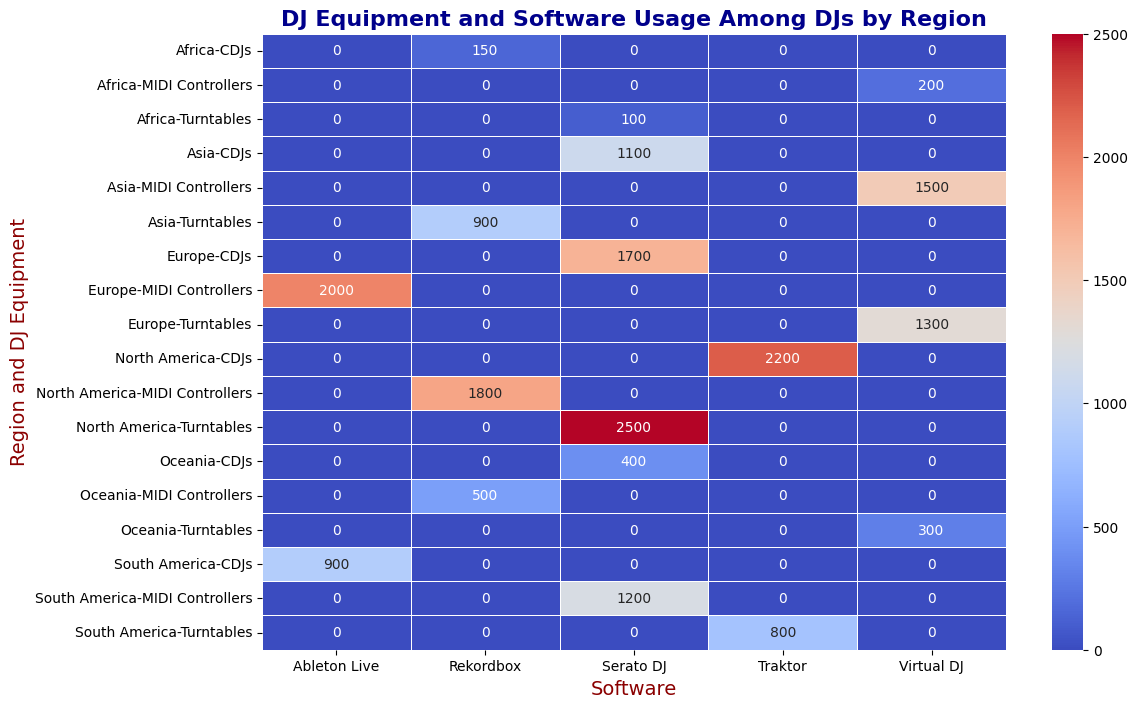Which region has the highest number of users for Serato DJ? To find this, locate the cells in the heatmap where the Software is "Serato DJ". North America, Europe, Asia, South America, and Oceania all have numbers in the "Serato DJ" column. Comparing these values shows that North America has the highest number of users with 2500 for Serato DJ.
Answer: North America What is the sum of users of Rekordbox in all regions? Add up the users from the cells in the "Rekordbox" column. According to the data: North America (1800), Asia (900), Oceania (500), and Africa (150). The total is 1800 + 900 + 500 + 150 = 3350.
Answer: 3350 Which piece of equipment is most widely used in Europe? To determine this, sum the user numbers for each piece of equipment under Europe. For Turntables, users are 1300; MIDI Controllers have 2000 users; CDJs have 1700 users. The highest number is 2000 for MIDI Controllers.
Answer: MIDI Controllers Compare the usage of Traktor software between North America and South America. Locate the cells where the Software is "Traktor" for North and South America. North America has 2200 users, while South America has 800 users. North America's usage is higher (2200 vs. 800).
Answer: North America Which software is the least used among DJs in Asia? Compare the user numbers for Asia across all software columns. The software numbers for Asia are: Rekordbox (900), Virtual DJ (1500), and Serato DJ (1100). Rekordbox has the smallest number of users.
Answer: Rekordbox What is the average number of users for Virtual DJ across all regions? Sum the users for Virtual DJ across all regions and divide by the number of regions using this software. The users are: Europe (1300), Asia (1500), Oceania (300), Africa (200). The total is 1300 + 1500 + 300 + 200 = 3300. There are 4 regions, so the average is 3300 / 4 = 825.
Answer: 825 What is the difference in the number of users for CDJs between North America and Asia? Locate the cells for CDJs in both North America and Asia. North America has 2200 users, and Asia has 1100 users. The difference is 2200 - 1100 = 1100.
Answer: 1100 Which region has the smallest number of users for Turntables? Compare the user numbers for Turntables across all regions. The user numbers are: North America (2500), Europe (1300), Asia (900), South America (800), Oceania (300), Africa (100). Africa has the smallest number (100).
Answer: Africa Which regions use Ableton Live and what are the total users in these regions? Locate the cells where the Software is "Ableton Live". Only Europe and South America use Ableton Live with users totaling: Europe (2000), South America (900), totalling 2000 + 900 = 2900.
Answer: Europe and South America, 2900 What is the predominant DJ equipment used across all regions? Sum the users for each DJ Equipment category across all regions. Turntables: 2500 + 1300 + 900 + 800 + 300 + 100 = 5900; MIDI Controllers: 1800 + 2000 + 1500 + 1200 + 500 + 200 = 7400; CDJs: 2200 + 1700 + 1100 + 900 + 400 + 150 = 6450. MIDI Controllers has the highest total (7400).
Answer: MIDI Controllers 